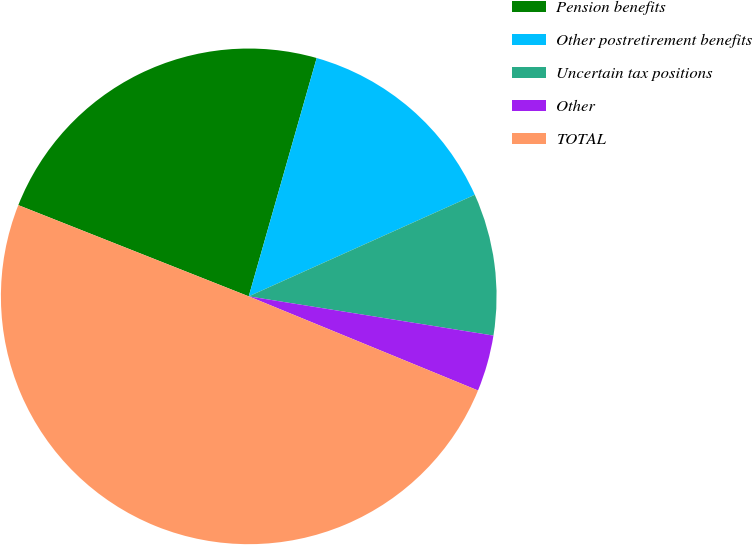Convert chart. <chart><loc_0><loc_0><loc_500><loc_500><pie_chart><fcel>Pension benefits<fcel>Other postretirement benefits<fcel>Uncertain tax positions<fcel>Other<fcel>TOTAL<nl><fcel>23.42%<fcel>13.86%<fcel>9.25%<fcel>3.67%<fcel>49.8%<nl></chart> 